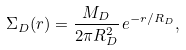Convert formula to latex. <formula><loc_0><loc_0><loc_500><loc_500>\Sigma _ { D } ( r ) = \frac { M _ { D } } { 2 \pi R _ { D } ^ { 2 } } \, e ^ { - r / R _ { D } } ,</formula> 